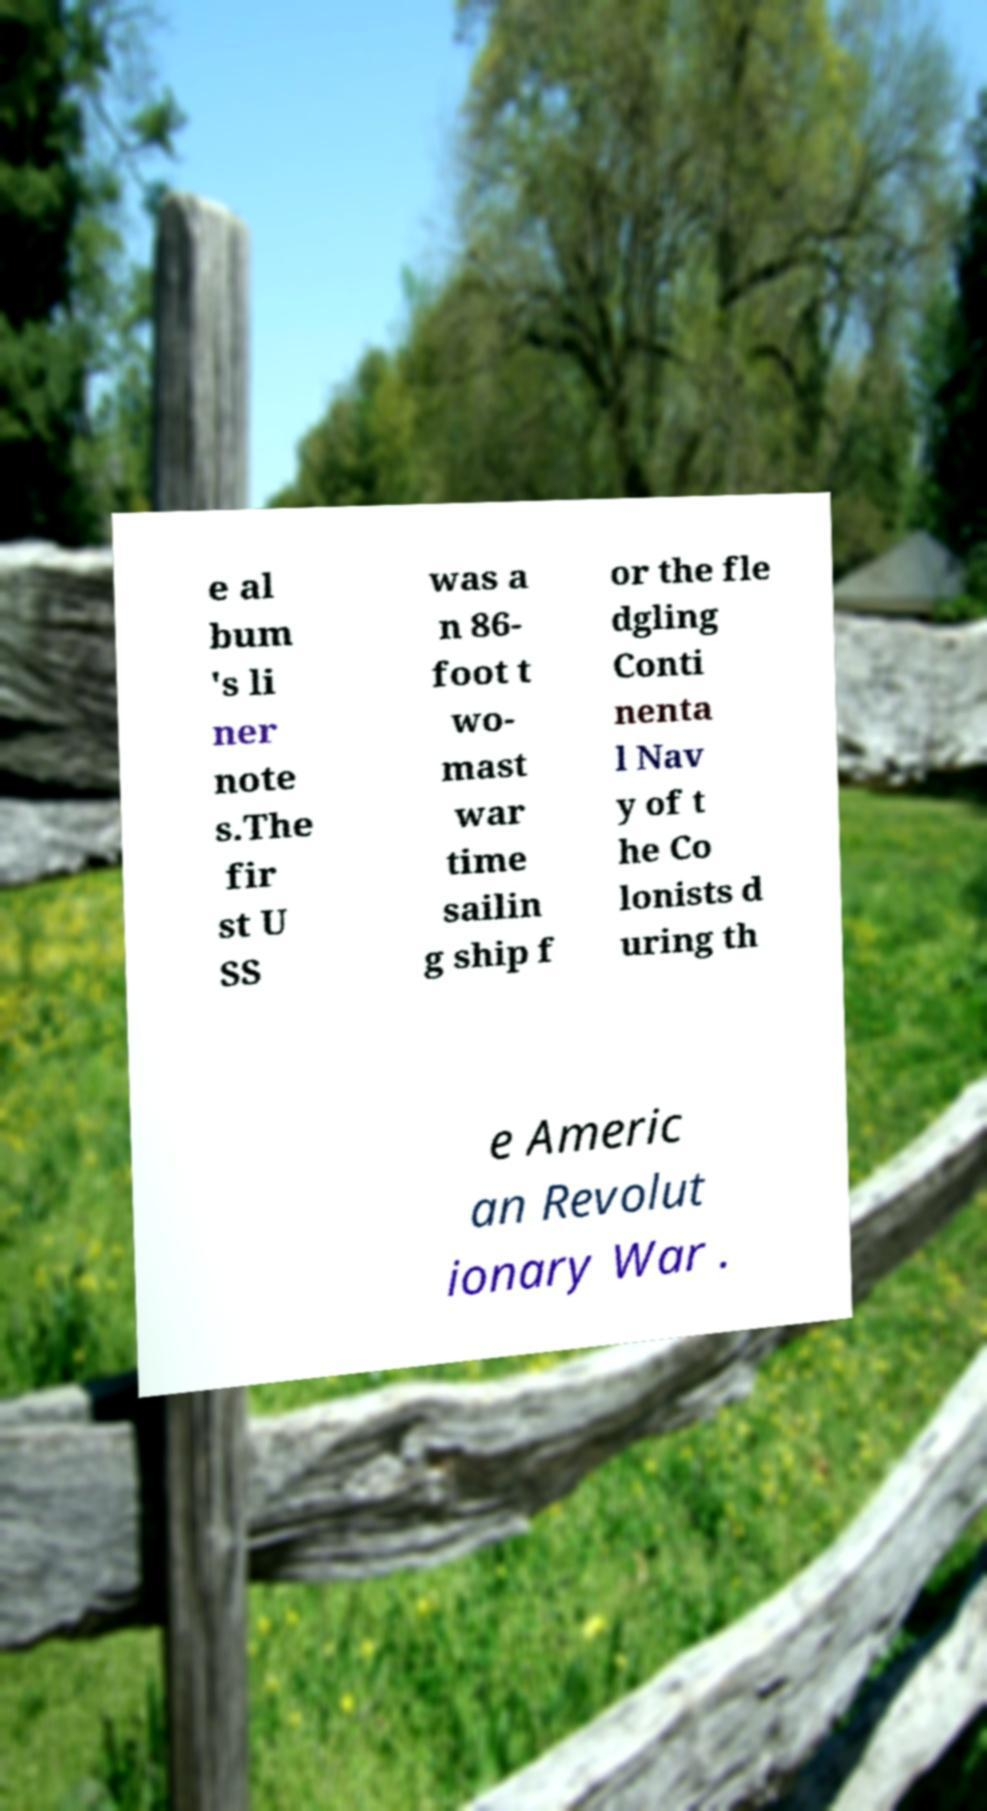Could you extract and type out the text from this image? e al bum 's li ner note s.The fir st U SS was a n 86- foot t wo- mast war time sailin g ship f or the fle dgling Conti nenta l Nav y of t he Co lonists d uring th e Americ an Revolut ionary War . 